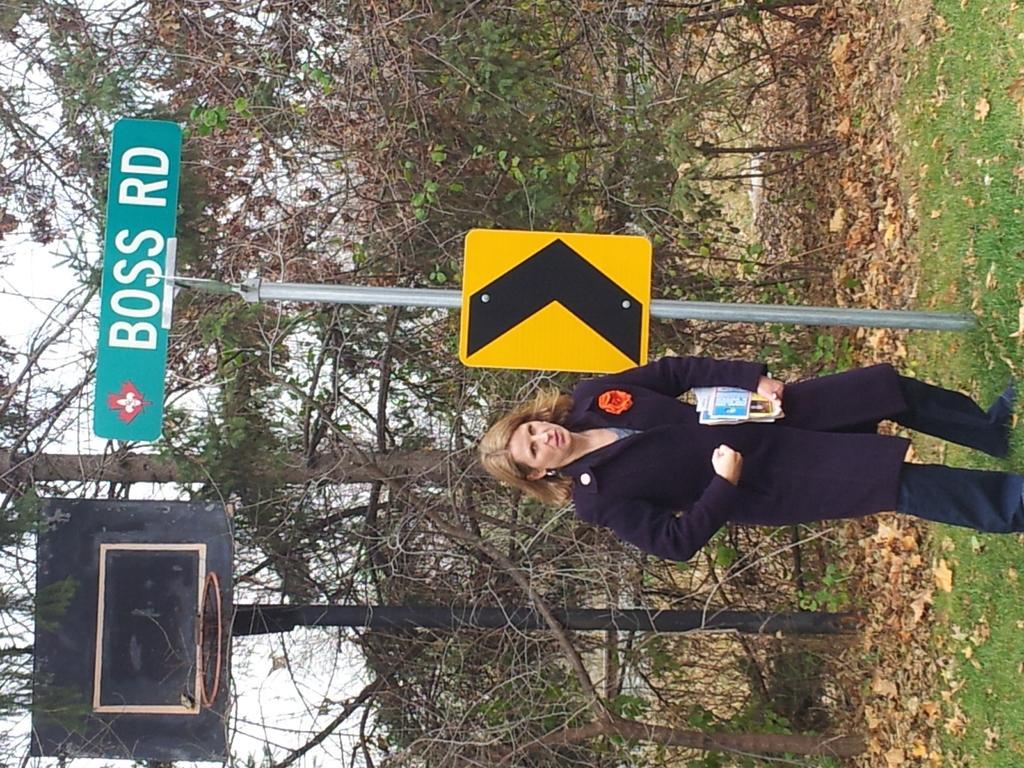Could you give a brief overview of what you see in this image? In this image in the center there is a woman standing holding papers in her hand. Behind the woman there is a board with some text written on it which is on the pole and there is grass on the ground and there are dry leaves on the ground. In the background there are trees and there is a pole which is black in colour. 